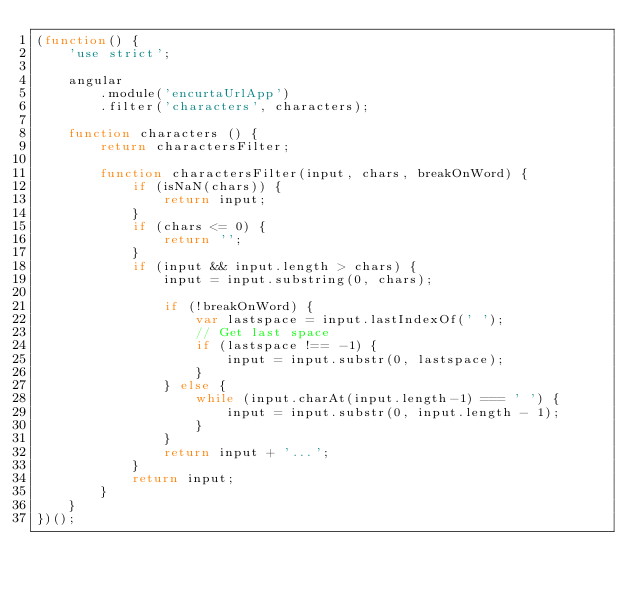<code> <loc_0><loc_0><loc_500><loc_500><_JavaScript_>(function() {
    'use strict';

    angular
        .module('encurtaUrlApp')
        .filter('characters', characters);

    function characters () {
        return charactersFilter;

        function charactersFilter(input, chars, breakOnWord) {
            if (isNaN(chars)) {
                return input;
            }
            if (chars <= 0) {
                return '';
            }
            if (input && input.length > chars) {
                input = input.substring(0, chars);

                if (!breakOnWord) {
                    var lastspace = input.lastIndexOf(' ');
                    // Get last space
                    if (lastspace !== -1) {
                        input = input.substr(0, lastspace);
                    }
                } else {
                    while (input.charAt(input.length-1) === ' ') {
                        input = input.substr(0, input.length - 1);
                    }
                }
                return input + '...';
            }
            return input;
        }
    }
})();
</code> 